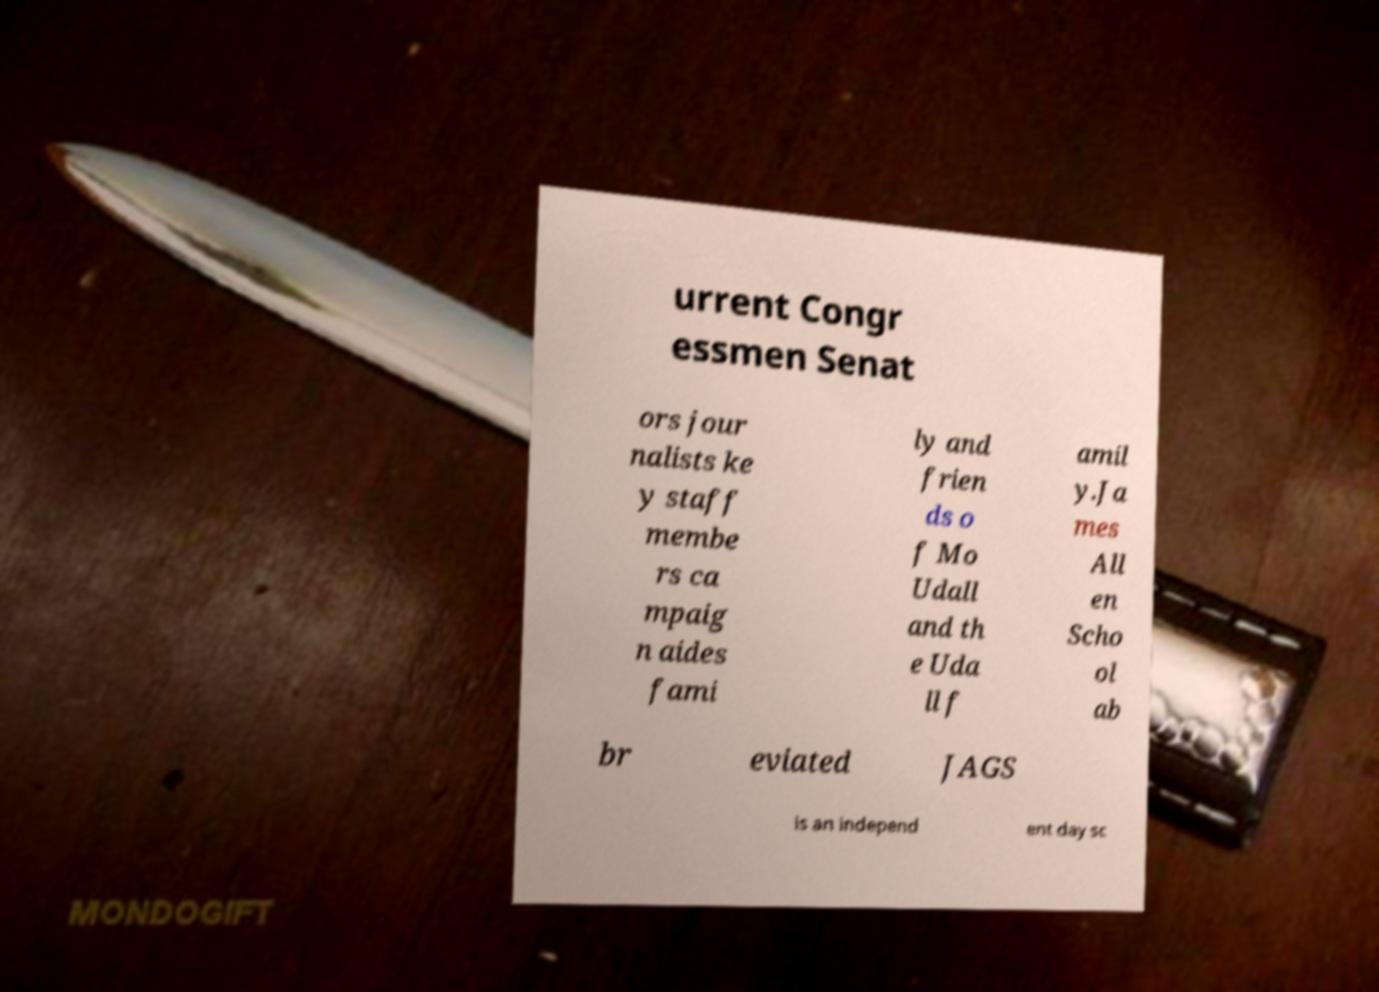I need the written content from this picture converted into text. Can you do that? urrent Congr essmen Senat ors jour nalists ke y staff membe rs ca mpaig n aides fami ly and frien ds o f Mo Udall and th e Uda ll f amil y.Ja mes All en Scho ol ab br eviated JAGS is an independ ent day sc 